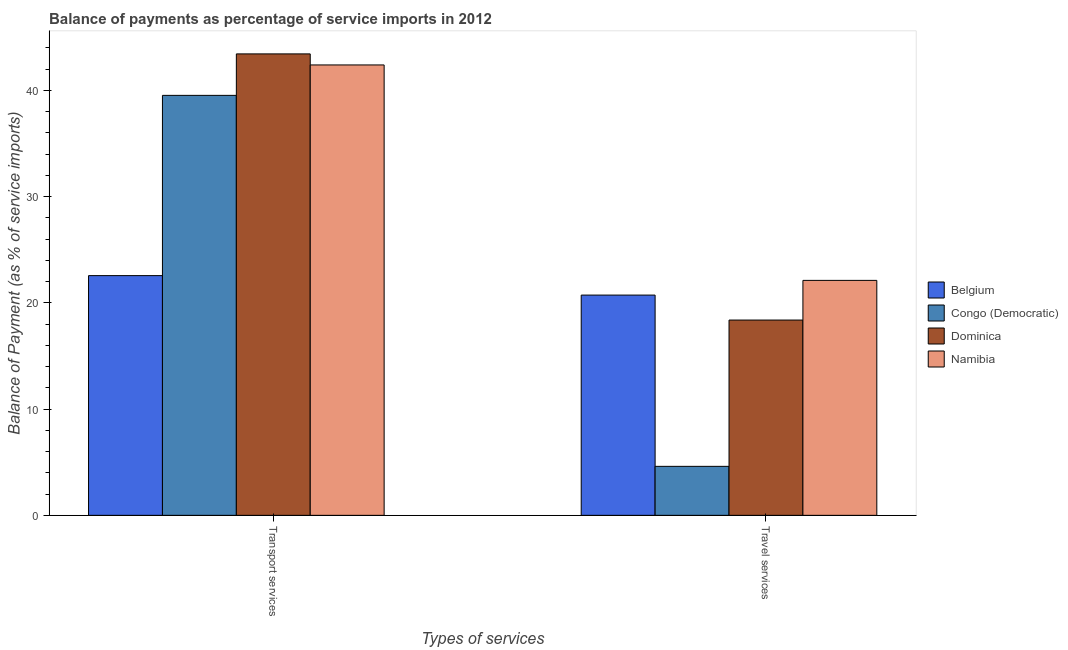How many different coloured bars are there?
Offer a terse response. 4. Are the number of bars on each tick of the X-axis equal?
Give a very brief answer. Yes. What is the label of the 2nd group of bars from the left?
Your answer should be very brief. Travel services. What is the balance of payments of transport services in Belgium?
Provide a succinct answer. 22.56. Across all countries, what is the maximum balance of payments of travel services?
Make the answer very short. 22.11. Across all countries, what is the minimum balance of payments of travel services?
Offer a terse response. 4.61. In which country was the balance of payments of transport services maximum?
Provide a short and direct response. Dominica. In which country was the balance of payments of travel services minimum?
Keep it short and to the point. Congo (Democratic). What is the total balance of payments of transport services in the graph?
Your answer should be very brief. 147.89. What is the difference between the balance of payments of travel services in Congo (Democratic) and that in Namibia?
Your answer should be compact. -17.5. What is the difference between the balance of payments of transport services in Dominica and the balance of payments of travel services in Belgium?
Offer a terse response. 22.7. What is the average balance of payments of travel services per country?
Provide a succinct answer. 16.46. What is the difference between the balance of payments of transport services and balance of payments of travel services in Namibia?
Your answer should be compact. 20.27. In how many countries, is the balance of payments of travel services greater than 22 %?
Your answer should be very brief. 1. What is the ratio of the balance of payments of transport services in Dominica to that in Namibia?
Provide a short and direct response. 1.02. Is the balance of payments of transport services in Congo (Democratic) less than that in Namibia?
Your answer should be very brief. Yes. What does the 1st bar from the left in Transport services represents?
Provide a short and direct response. Belgium. What does the 2nd bar from the right in Transport services represents?
Offer a terse response. Dominica. Are all the bars in the graph horizontal?
Provide a short and direct response. No. Does the graph contain any zero values?
Ensure brevity in your answer.  No. Does the graph contain grids?
Provide a short and direct response. No. How are the legend labels stacked?
Provide a short and direct response. Vertical. What is the title of the graph?
Offer a very short reply. Balance of payments as percentage of service imports in 2012. What is the label or title of the X-axis?
Provide a succinct answer. Types of services. What is the label or title of the Y-axis?
Your response must be concise. Balance of Payment (as % of service imports). What is the Balance of Payment (as % of service imports) of Belgium in Transport services?
Your answer should be very brief. 22.56. What is the Balance of Payment (as % of service imports) of Congo (Democratic) in Transport services?
Provide a short and direct response. 39.52. What is the Balance of Payment (as % of service imports) in Dominica in Transport services?
Make the answer very short. 43.43. What is the Balance of Payment (as % of service imports) of Namibia in Transport services?
Your answer should be compact. 42.39. What is the Balance of Payment (as % of service imports) of Belgium in Travel services?
Make the answer very short. 20.73. What is the Balance of Payment (as % of service imports) of Congo (Democratic) in Travel services?
Give a very brief answer. 4.61. What is the Balance of Payment (as % of service imports) in Dominica in Travel services?
Offer a terse response. 18.38. What is the Balance of Payment (as % of service imports) in Namibia in Travel services?
Your response must be concise. 22.11. Across all Types of services, what is the maximum Balance of Payment (as % of service imports) of Belgium?
Provide a succinct answer. 22.56. Across all Types of services, what is the maximum Balance of Payment (as % of service imports) in Congo (Democratic)?
Offer a terse response. 39.52. Across all Types of services, what is the maximum Balance of Payment (as % of service imports) of Dominica?
Offer a very short reply. 43.43. Across all Types of services, what is the maximum Balance of Payment (as % of service imports) of Namibia?
Ensure brevity in your answer.  42.39. Across all Types of services, what is the minimum Balance of Payment (as % of service imports) in Belgium?
Provide a short and direct response. 20.73. Across all Types of services, what is the minimum Balance of Payment (as % of service imports) in Congo (Democratic)?
Your answer should be compact. 4.61. Across all Types of services, what is the minimum Balance of Payment (as % of service imports) in Dominica?
Your response must be concise. 18.38. Across all Types of services, what is the minimum Balance of Payment (as % of service imports) of Namibia?
Your answer should be very brief. 22.11. What is the total Balance of Payment (as % of service imports) in Belgium in the graph?
Provide a succinct answer. 43.29. What is the total Balance of Payment (as % of service imports) of Congo (Democratic) in the graph?
Give a very brief answer. 44.13. What is the total Balance of Payment (as % of service imports) in Dominica in the graph?
Offer a very short reply. 61.8. What is the total Balance of Payment (as % of service imports) in Namibia in the graph?
Offer a very short reply. 64.5. What is the difference between the Balance of Payment (as % of service imports) in Belgium in Transport services and that in Travel services?
Offer a terse response. 1.83. What is the difference between the Balance of Payment (as % of service imports) of Congo (Democratic) in Transport services and that in Travel services?
Provide a succinct answer. 34.91. What is the difference between the Balance of Payment (as % of service imports) of Dominica in Transport services and that in Travel services?
Make the answer very short. 25.05. What is the difference between the Balance of Payment (as % of service imports) in Namibia in Transport services and that in Travel services?
Keep it short and to the point. 20.27. What is the difference between the Balance of Payment (as % of service imports) in Belgium in Transport services and the Balance of Payment (as % of service imports) in Congo (Democratic) in Travel services?
Your answer should be compact. 17.95. What is the difference between the Balance of Payment (as % of service imports) of Belgium in Transport services and the Balance of Payment (as % of service imports) of Dominica in Travel services?
Give a very brief answer. 4.18. What is the difference between the Balance of Payment (as % of service imports) in Belgium in Transport services and the Balance of Payment (as % of service imports) in Namibia in Travel services?
Ensure brevity in your answer.  0.45. What is the difference between the Balance of Payment (as % of service imports) of Congo (Democratic) in Transport services and the Balance of Payment (as % of service imports) of Dominica in Travel services?
Your response must be concise. 21.14. What is the difference between the Balance of Payment (as % of service imports) in Congo (Democratic) in Transport services and the Balance of Payment (as % of service imports) in Namibia in Travel services?
Your answer should be very brief. 17.41. What is the difference between the Balance of Payment (as % of service imports) of Dominica in Transport services and the Balance of Payment (as % of service imports) of Namibia in Travel services?
Your response must be concise. 21.31. What is the average Balance of Payment (as % of service imports) of Belgium per Types of services?
Make the answer very short. 21.64. What is the average Balance of Payment (as % of service imports) in Congo (Democratic) per Types of services?
Provide a succinct answer. 22.07. What is the average Balance of Payment (as % of service imports) of Dominica per Types of services?
Your response must be concise. 30.9. What is the average Balance of Payment (as % of service imports) in Namibia per Types of services?
Keep it short and to the point. 32.25. What is the difference between the Balance of Payment (as % of service imports) of Belgium and Balance of Payment (as % of service imports) of Congo (Democratic) in Transport services?
Make the answer very short. -16.96. What is the difference between the Balance of Payment (as % of service imports) in Belgium and Balance of Payment (as % of service imports) in Dominica in Transport services?
Keep it short and to the point. -20.87. What is the difference between the Balance of Payment (as % of service imports) of Belgium and Balance of Payment (as % of service imports) of Namibia in Transport services?
Keep it short and to the point. -19.83. What is the difference between the Balance of Payment (as % of service imports) of Congo (Democratic) and Balance of Payment (as % of service imports) of Dominica in Transport services?
Provide a short and direct response. -3.9. What is the difference between the Balance of Payment (as % of service imports) of Congo (Democratic) and Balance of Payment (as % of service imports) of Namibia in Transport services?
Offer a very short reply. -2.86. What is the difference between the Balance of Payment (as % of service imports) in Dominica and Balance of Payment (as % of service imports) in Namibia in Transport services?
Your answer should be very brief. 1.04. What is the difference between the Balance of Payment (as % of service imports) in Belgium and Balance of Payment (as % of service imports) in Congo (Democratic) in Travel services?
Make the answer very short. 16.12. What is the difference between the Balance of Payment (as % of service imports) in Belgium and Balance of Payment (as % of service imports) in Dominica in Travel services?
Keep it short and to the point. 2.35. What is the difference between the Balance of Payment (as % of service imports) in Belgium and Balance of Payment (as % of service imports) in Namibia in Travel services?
Provide a short and direct response. -1.38. What is the difference between the Balance of Payment (as % of service imports) of Congo (Democratic) and Balance of Payment (as % of service imports) of Dominica in Travel services?
Make the answer very short. -13.77. What is the difference between the Balance of Payment (as % of service imports) of Congo (Democratic) and Balance of Payment (as % of service imports) of Namibia in Travel services?
Offer a terse response. -17.5. What is the difference between the Balance of Payment (as % of service imports) of Dominica and Balance of Payment (as % of service imports) of Namibia in Travel services?
Give a very brief answer. -3.73. What is the ratio of the Balance of Payment (as % of service imports) of Belgium in Transport services to that in Travel services?
Ensure brevity in your answer.  1.09. What is the ratio of the Balance of Payment (as % of service imports) of Congo (Democratic) in Transport services to that in Travel services?
Your answer should be very brief. 8.57. What is the ratio of the Balance of Payment (as % of service imports) of Dominica in Transport services to that in Travel services?
Provide a short and direct response. 2.36. What is the ratio of the Balance of Payment (as % of service imports) in Namibia in Transport services to that in Travel services?
Make the answer very short. 1.92. What is the difference between the highest and the second highest Balance of Payment (as % of service imports) of Belgium?
Offer a terse response. 1.83. What is the difference between the highest and the second highest Balance of Payment (as % of service imports) in Congo (Democratic)?
Make the answer very short. 34.91. What is the difference between the highest and the second highest Balance of Payment (as % of service imports) of Dominica?
Ensure brevity in your answer.  25.05. What is the difference between the highest and the second highest Balance of Payment (as % of service imports) of Namibia?
Keep it short and to the point. 20.27. What is the difference between the highest and the lowest Balance of Payment (as % of service imports) of Belgium?
Keep it short and to the point. 1.83. What is the difference between the highest and the lowest Balance of Payment (as % of service imports) in Congo (Democratic)?
Keep it short and to the point. 34.91. What is the difference between the highest and the lowest Balance of Payment (as % of service imports) in Dominica?
Make the answer very short. 25.05. What is the difference between the highest and the lowest Balance of Payment (as % of service imports) in Namibia?
Offer a very short reply. 20.27. 